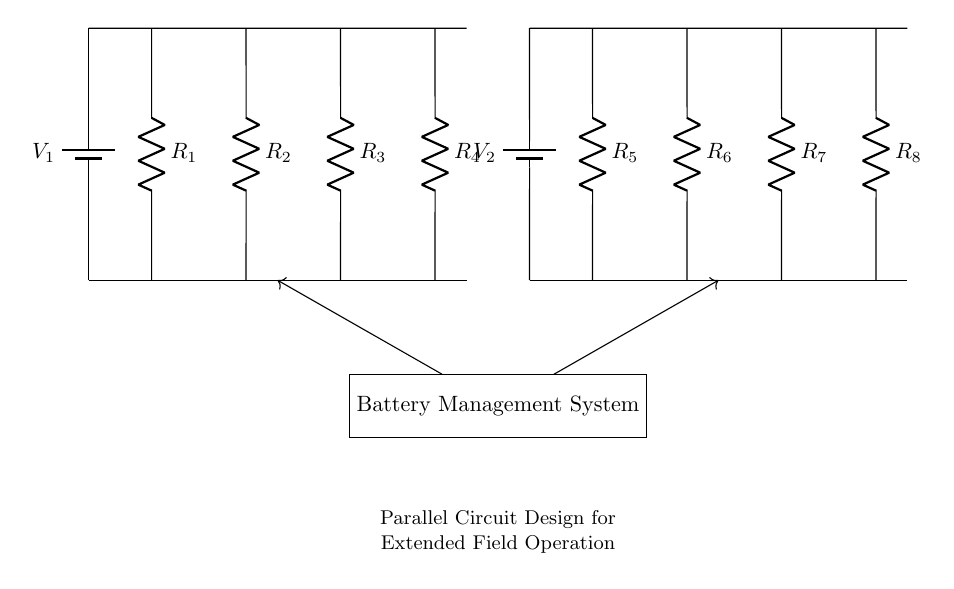What is the total number of resistors in this circuit? There are eight resistors labeled R1 to R8, which can be counted directly from the diagram.
Answer: Eight What are the voltage sources in this circuit? The circuit contains two voltage sources, V1 and V2, which provide power to the resistors connected in parallel.
Answer: V1 and V2 How many branches does this parallel circuit have? The parallel circuit has four branches coming from each voltage source, with each branch containing a resistor. Each voltage source also has its own separate set of resistors.
Answer: Four What happens to total resistance if one resistor fails in this circuit? In a parallel configuration, if one resistor fails, the total resistance decreases because the remaining resistors still provide pathways for current. The total resistance is found using the formula for parallel circuits; thus, it will still allow current flow.
Answer: Decreases Which resistors are connected to the first voltage source? The resistors connected to the first voltage source, V1, are R1, R2, R3, and R4, as they are drawn connected to that voltage source in the diagram.
Answer: R1, R2, R3, R4 Explain the function of the battery management system in this diagram. The battery management system integrates the inputs from both voltage sources and controls the distribution of power to the resistors, ensuring efficient operation and protection of the batteries during extended use in the field.
Answer: Power distribution and protection 